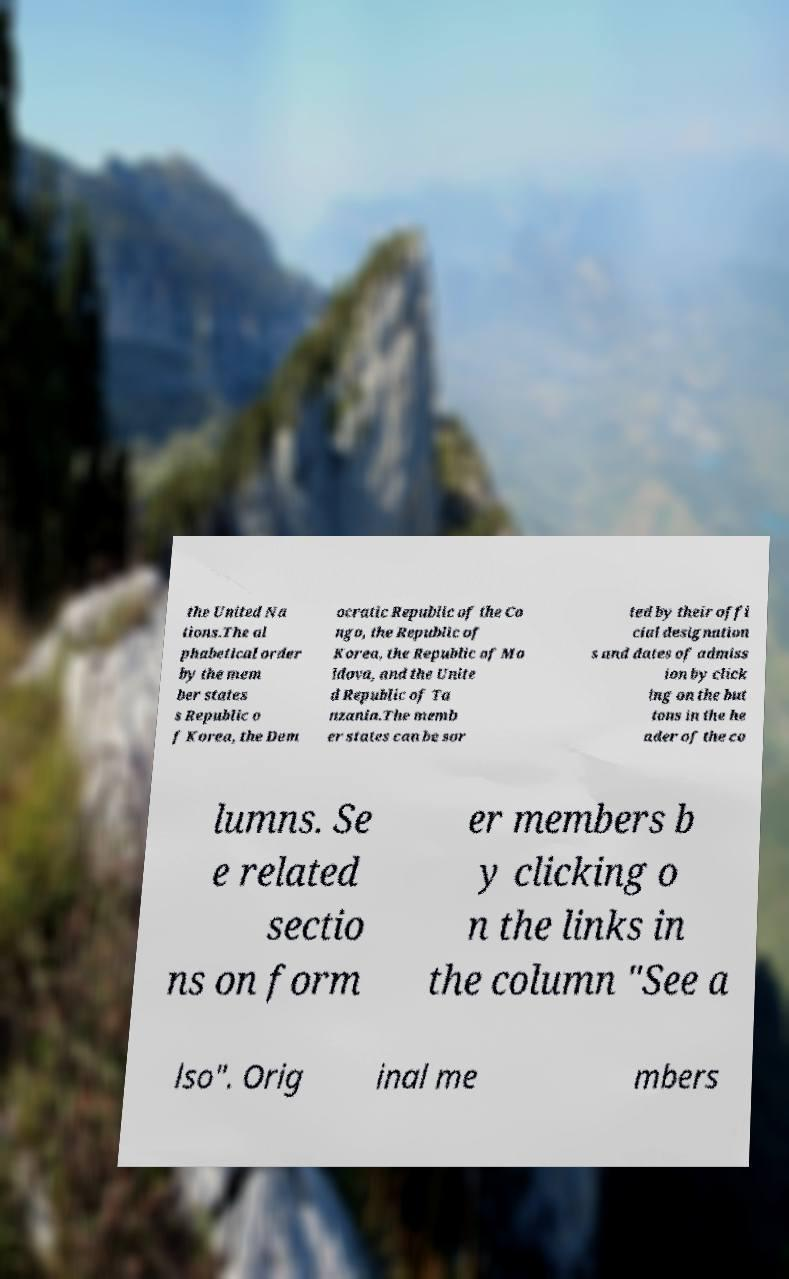Can you accurately transcribe the text from the provided image for me? the United Na tions.The al phabetical order by the mem ber states s Republic o f Korea, the Dem ocratic Republic of the Co ngo, the Republic of Korea, the Republic of Mo ldova, and the Unite d Republic of Ta nzania.The memb er states can be sor ted by their offi cial designation s and dates of admiss ion by click ing on the but tons in the he ader of the co lumns. Se e related sectio ns on form er members b y clicking o n the links in the column "See a lso". Orig inal me mbers 